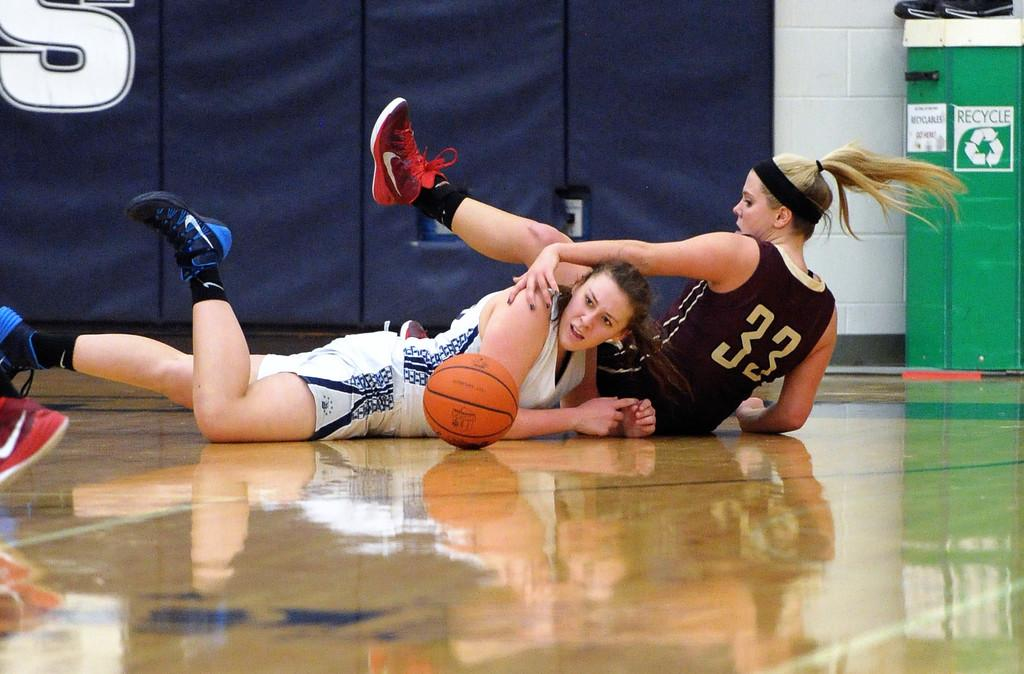<image>
Give a short and clear explanation of the subsequent image. two girls playing basketball and one with the number 33 on it 